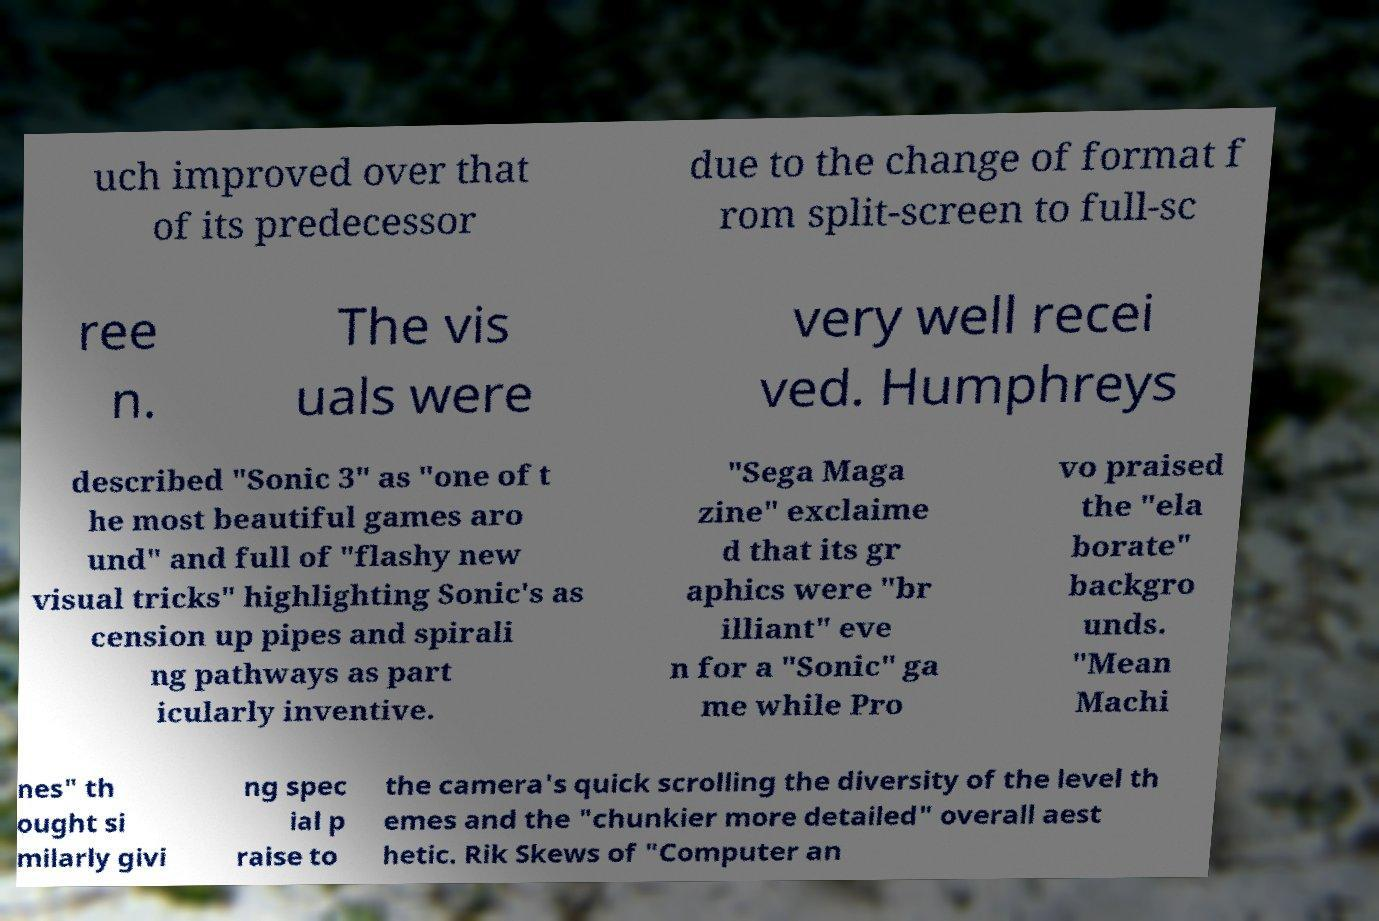There's text embedded in this image that I need extracted. Can you transcribe it verbatim? uch improved over that of its predecessor due to the change of format f rom split-screen to full-sc ree n. The vis uals were very well recei ved. Humphreys described "Sonic 3" as "one of t he most beautiful games aro und" and full of "flashy new visual tricks" highlighting Sonic's as cension up pipes and spirali ng pathways as part icularly inventive. "Sega Maga zine" exclaime d that its gr aphics were "br illiant" eve n for a "Sonic" ga me while Pro vo praised the "ela borate" backgro unds. "Mean Machi nes" th ought si milarly givi ng spec ial p raise to the camera's quick scrolling the diversity of the level th emes and the "chunkier more detailed" overall aest hetic. Rik Skews of "Computer an 